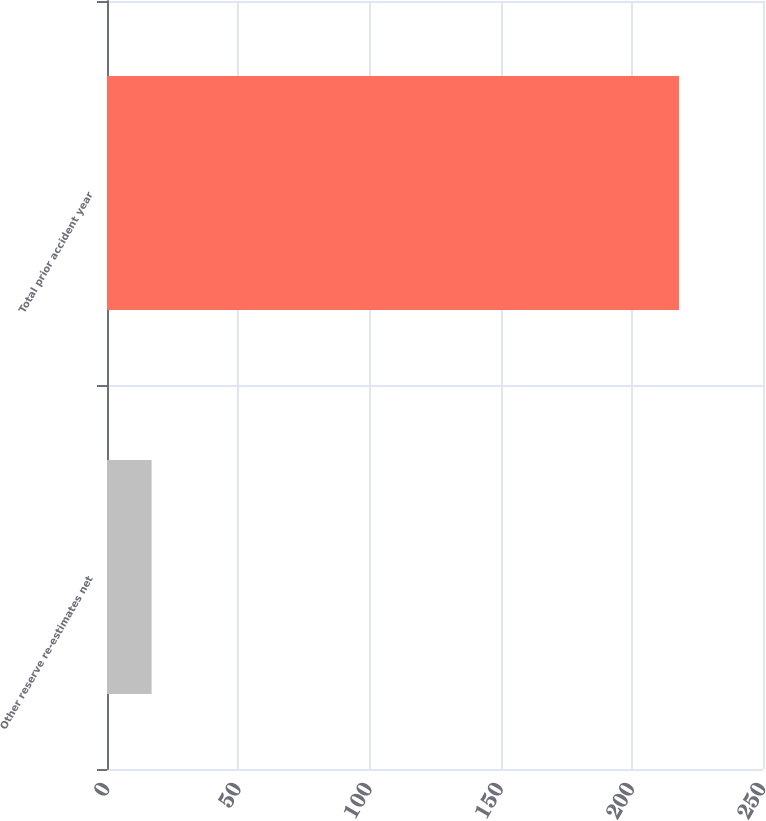Convert chart to OTSL. <chart><loc_0><loc_0><loc_500><loc_500><bar_chart><fcel>Other reserve re-estimates net<fcel>Total prior accident year<nl><fcel>17<fcel>218<nl></chart> 